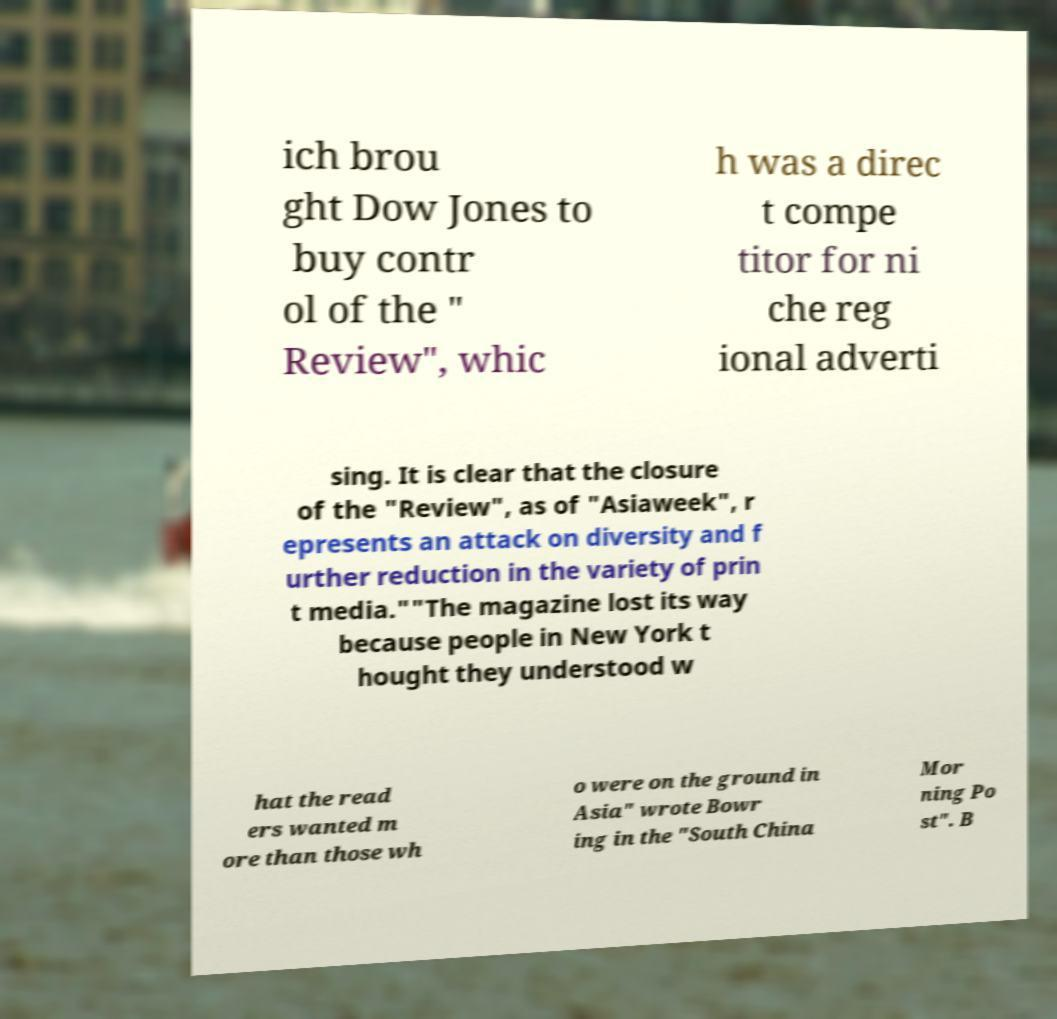Please identify and transcribe the text found in this image. ich brou ght Dow Jones to buy contr ol of the " Review", whic h was a direc t compe titor for ni che reg ional adverti sing. It is clear that the closure of the "Review", as of "Asiaweek", r epresents an attack on diversity and f urther reduction in the variety of prin t media.""The magazine lost its way because people in New York t hought they understood w hat the read ers wanted m ore than those wh o were on the ground in Asia" wrote Bowr ing in the "South China Mor ning Po st". B 